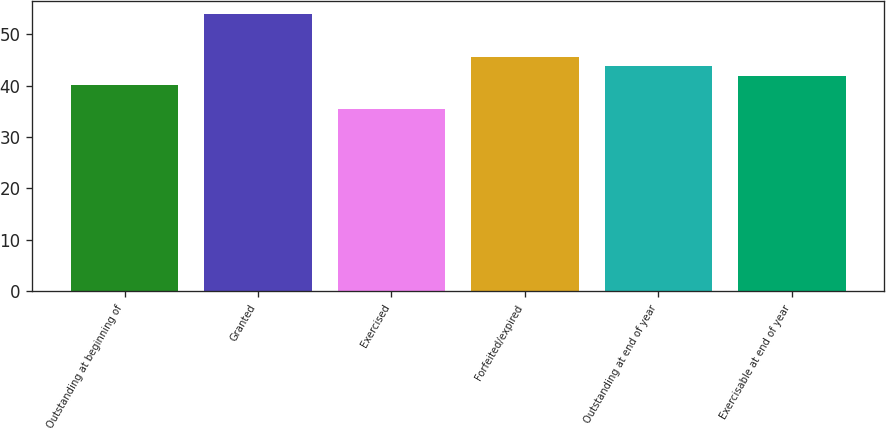Convert chart. <chart><loc_0><loc_0><loc_500><loc_500><bar_chart><fcel>Outstanding at beginning of<fcel>Granted<fcel>Exercised<fcel>Forfeited/expired<fcel>Outstanding at end of year<fcel>Exercisable at end of year<nl><fcel>40.05<fcel>53.82<fcel>35.4<fcel>45.57<fcel>43.73<fcel>41.89<nl></chart> 